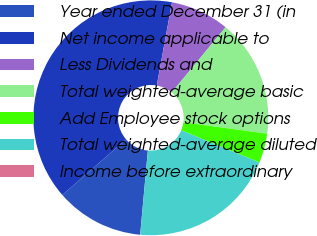Convert chart. <chart><loc_0><loc_0><loc_500><loc_500><pie_chart><fcel>Year ended December 31 (in<fcel>Net income applicable to<fcel>Less Dividends and<fcel>Total weighted-average basic<fcel>Add Employee stock options<fcel>Total weighted-average diluted<fcel>Income before extraordinary<nl><fcel>12.14%<fcel>39.29%<fcel>8.1%<fcel>16.18%<fcel>4.05%<fcel>20.23%<fcel>0.01%<nl></chart> 